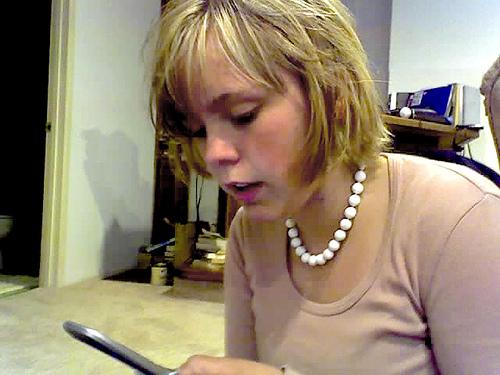What is the girl looking at?
Short answer required. Phone. Is this female elderly?
Short answer required. No. How many pearls make up the woman's necklace?
Keep it brief. 30. What is she holding in her hand?
Keep it brief. Phone. 